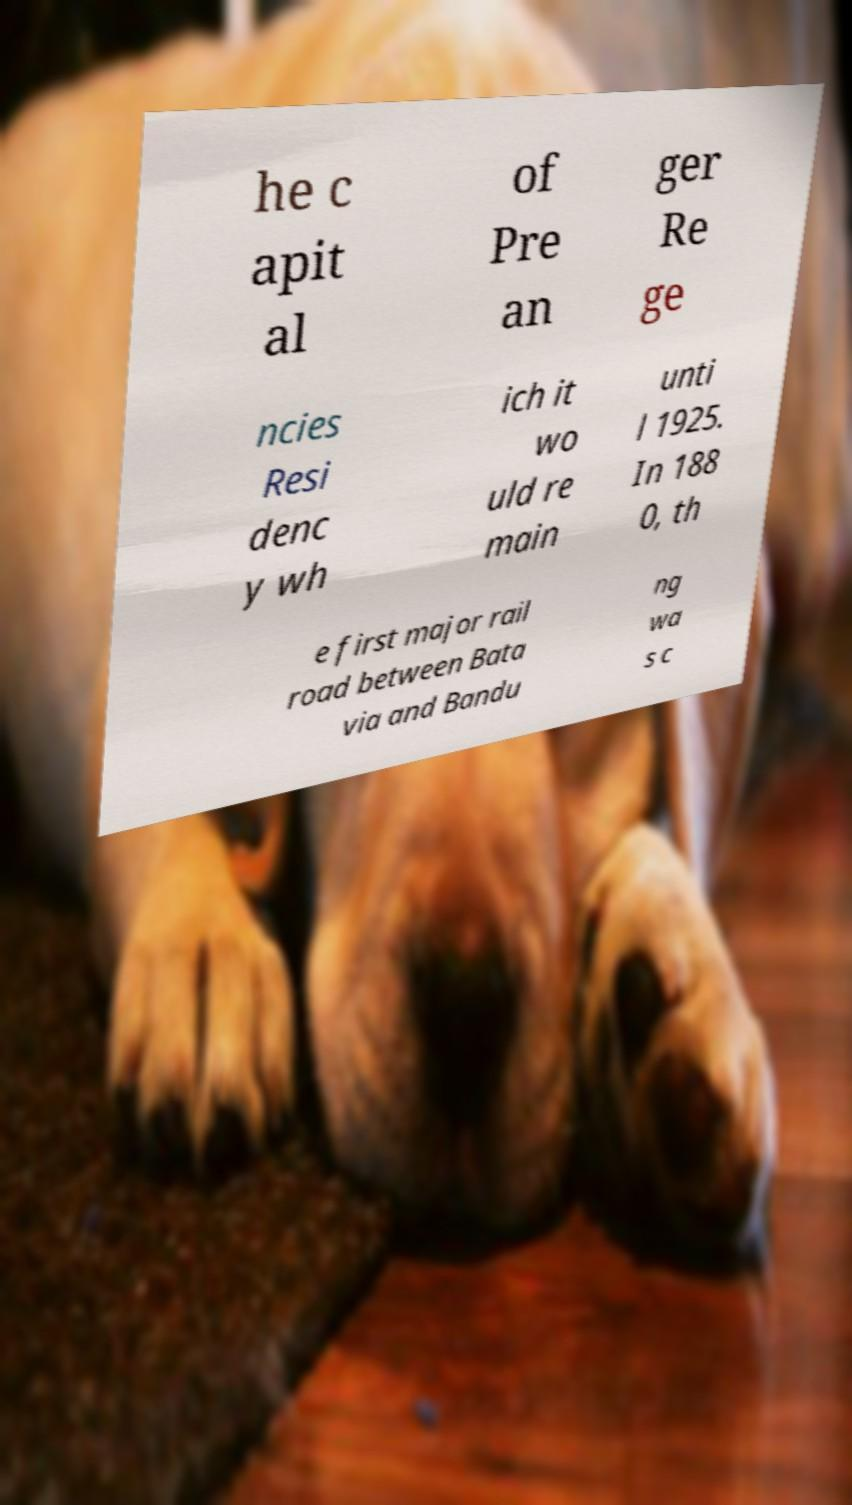Please identify and transcribe the text found in this image. he c apit al of Pre an ger Re ge ncies Resi denc y wh ich it wo uld re main unti l 1925. In 188 0, th e first major rail road between Bata via and Bandu ng wa s c 